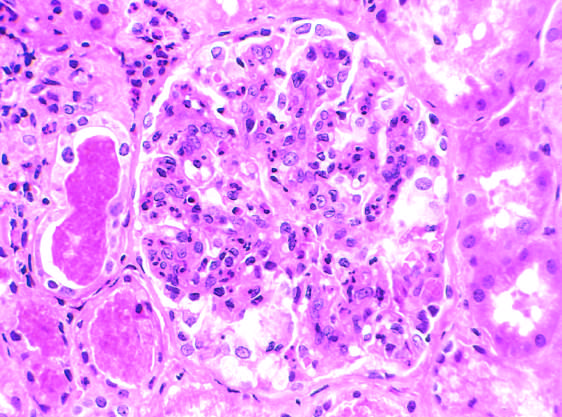re reversibly injured myocardium in the tubules?
Answer the question using a single word or phrase. No 